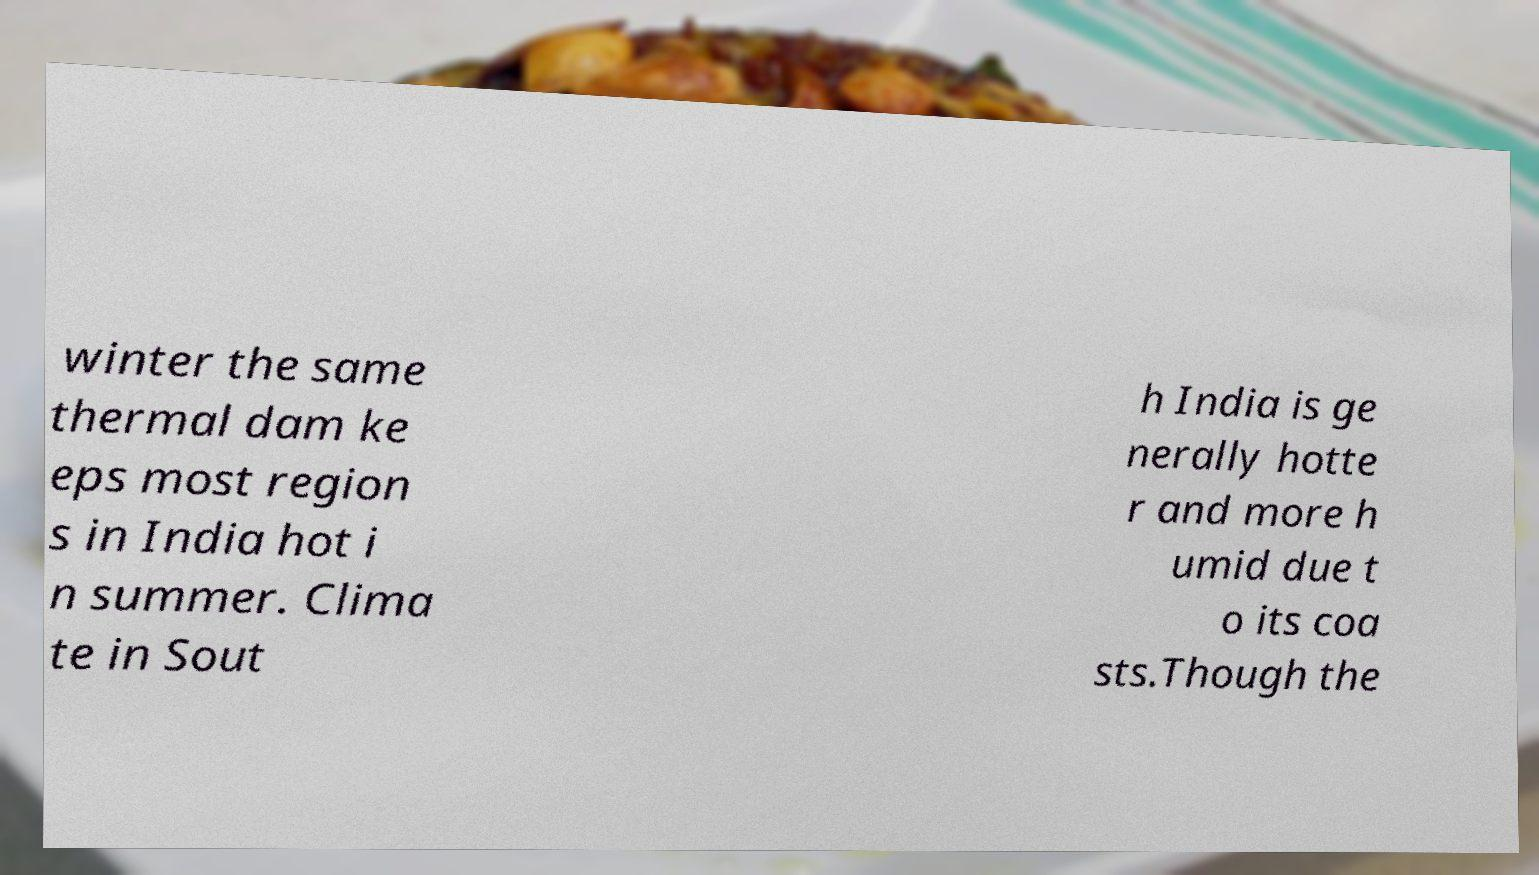There's text embedded in this image that I need extracted. Can you transcribe it verbatim? winter the same thermal dam ke eps most region s in India hot i n summer. Clima te in Sout h India is ge nerally hotte r and more h umid due t o its coa sts.Though the 